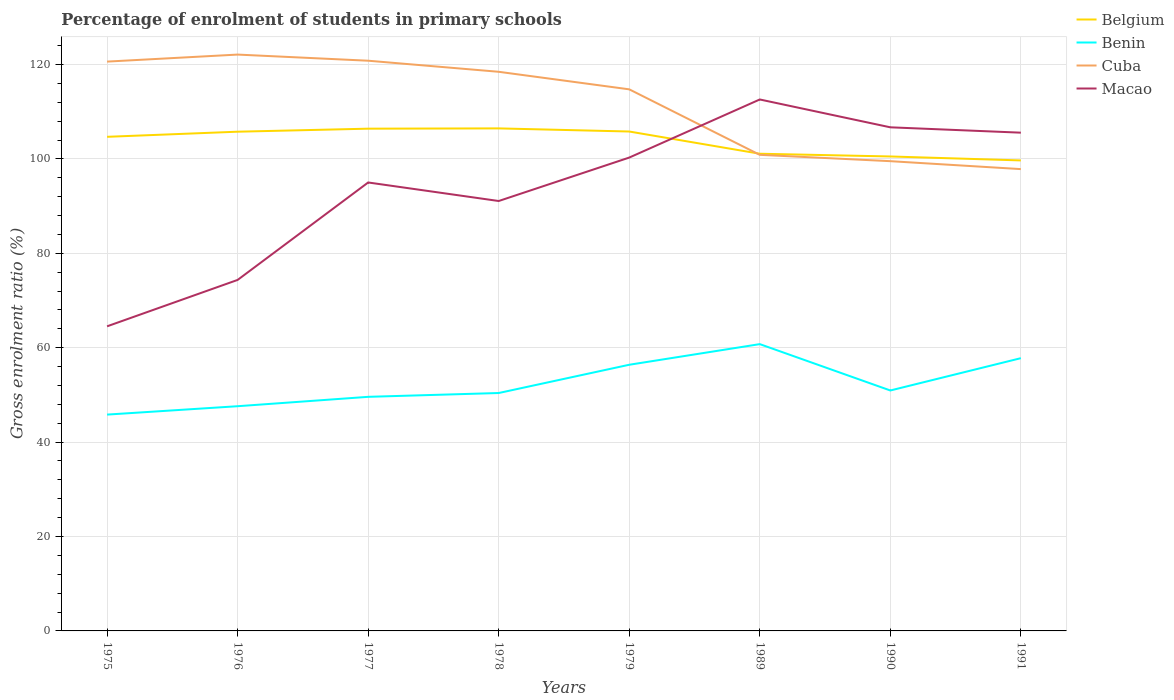How many different coloured lines are there?
Make the answer very short. 4. Does the line corresponding to Cuba intersect with the line corresponding to Macao?
Keep it short and to the point. Yes. Across all years, what is the maximum percentage of students enrolled in primary schools in Belgium?
Offer a terse response. 99.68. In which year was the percentage of students enrolled in primary schools in Belgium maximum?
Make the answer very short. 1991. What is the total percentage of students enrolled in primary schools in Cuba in the graph?
Keep it short and to the point. 3.03. What is the difference between the highest and the second highest percentage of students enrolled in primary schools in Benin?
Give a very brief answer. 14.93. What is the difference between the highest and the lowest percentage of students enrolled in primary schools in Cuba?
Offer a very short reply. 5. Are the values on the major ticks of Y-axis written in scientific E-notation?
Your answer should be compact. No. Where does the legend appear in the graph?
Keep it short and to the point. Top right. How many legend labels are there?
Offer a terse response. 4. How are the legend labels stacked?
Ensure brevity in your answer.  Vertical. What is the title of the graph?
Keep it short and to the point. Percentage of enrolment of students in primary schools. Does "Mauritania" appear as one of the legend labels in the graph?
Offer a very short reply. No. What is the label or title of the Y-axis?
Give a very brief answer. Gross enrolment ratio (%). What is the Gross enrolment ratio (%) in Belgium in 1975?
Give a very brief answer. 104.68. What is the Gross enrolment ratio (%) of Benin in 1975?
Your response must be concise. 45.83. What is the Gross enrolment ratio (%) in Cuba in 1975?
Your answer should be compact. 120.61. What is the Gross enrolment ratio (%) of Macao in 1975?
Your response must be concise. 64.53. What is the Gross enrolment ratio (%) of Belgium in 1976?
Ensure brevity in your answer.  105.76. What is the Gross enrolment ratio (%) of Benin in 1976?
Provide a succinct answer. 47.6. What is the Gross enrolment ratio (%) in Cuba in 1976?
Give a very brief answer. 122.1. What is the Gross enrolment ratio (%) in Macao in 1976?
Offer a very short reply. 74.36. What is the Gross enrolment ratio (%) of Belgium in 1977?
Give a very brief answer. 106.4. What is the Gross enrolment ratio (%) in Benin in 1977?
Your answer should be very brief. 49.59. What is the Gross enrolment ratio (%) of Cuba in 1977?
Ensure brevity in your answer.  120.8. What is the Gross enrolment ratio (%) of Macao in 1977?
Give a very brief answer. 95. What is the Gross enrolment ratio (%) of Belgium in 1978?
Provide a succinct answer. 106.46. What is the Gross enrolment ratio (%) of Benin in 1978?
Ensure brevity in your answer.  50.4. What is the Gross enrolment ratio (%) in Cuba in 1978?
Give a very brief answer. 118.45. What is the Gross enrolment ratio (%) in Macao in 1978?
Ensure brevity in your answer.  91.08. What is the Gross enrolment ratio (%) in Belgium in 1979?
Provide a succinct answer. 105.8. What is the Gross enrolment ratio (%) in Benin in 1979?
Keep it short and to the point. 56.39. What is the Gross enrolment ratio (%) of Cuba in 1979?
Your answer should be very brief. 114.73. What is the Gross enrolment ratio (%) in Macao in 1979?
Give a very brief answer. 100.28. What is the Gross enrolment ratio (%) in Belgium in 1989?
Offer a very short reply. 101.09. What is the Gross enrolment ratio (%) of Benin in 1989?
Keep it short and to the point. 60.76. What is the Gross enrolment ratio (%) of Cuba in 1989?
Your response must be concise. 100.86. What is the Gross enrolment ratio (%) of Macao in 1989?
Make the answer very short. 112.59. What is the Gross enrolment ratio (%) in Belgium in 1990?
Ensure brevity in your answer.  100.51. What is the Gross enrolment ratio (%) in Benin in 1990?
Offer a very short reply. 50.94. What is the Gross enrolment ratio (%) of Cuba in 1990?
Your answer should be very brief. 99.52. What is the Gross enrolment ratio (%) in Macao in 1990?
Keep it short and to the point. 106.69. What is the Gross enrolment ratio (%) in Belgium in 1991?
Give a very brief answer. 99.68. What is the Gross enrolment ratio (%) of Benin in 1991?
Your response must be concise. 57.78. What is the Gross enrolment ratio (%) of Cuba in 1991?
Make the answer very short. 97.83. What is the Gross enrolment ratio (%) in Macao in 1991?
Keep it short and to the point. 105.55. Across all years, what is the maximum Gross enrolment ratio (%) of Belgium?
Make the answer very short. 106.46. Across all years, what is the maximum Gross enrolment ratio (%) in Benin?
Give a very brief answer. 60.76. Across all years, what is the maximum Gross enrolment ratio (%) in Cuba?
Keep it short and to the point. 122.1. Across all years, what is the maximum Gross enrolment ratio (%) of Macao?
Your response must be concise. 112.59. Across all years, what is the minimum Gross enrolment ratio (%) of Belgium?
Your answer should be very brief. 99.68. Across all years, what is the minimum Gross enrolment ratio (%) in Benin?
Give a very brief answer. 45.83. Across all years, what is the minimum Gross enrolment ratio (%) of Cuba?
Offer a very short reply. 97.83. Across all years, what is the minimum Gross enrolment ratio (%) in Macao?
Provide a short and direct response. 64.53. What is the total Gross enrolment ratio (%) in Belgium in the graph?
Ensure brevity in your answer.  830.38. What is the total Gross enrolment ratio (%) in Benin in the graph?
Your answer should be very brief. 419.29. What is the total Gross enrolment ratio (%) in Cuba in the graph?
Keep it short and to the point. 894.9. What is the total Gross enrolment ratio (%) in Macao in the graph?
Offer a terse response. 750.08. What is the difference between the Gross enrolment ratio (%) in Belgium in 1975 and that in 1976?
Provide a succinct answer. -1.08. What is the difference between the Gross enrolment ratio (%) in Benin in 1975 and that in 1976?
Your answer should be compact. -1.78. What is the difference between the Gross enrolment ratio (%) in Cuba in 1975 and that in 1976?
Make the answer very short. -1.49. What is the difference between the Gross enrolment ratio (%) in Macao in 1975 and that in 1976?
Provide a succinct answer. -9.83. What is the difference between the Gross enrolment ratio (%) of Belgium in 1975 and that in 1977?
Provide a succinct answer. -1.72. What is the difference between the Gross enrolment ratio (%) in Benin in 1975 and that in 1977?
Keep it short and to the point. -3.76. What is the difference between the Gross enrolment ratio (%) of Cuba in 1975 and that in 1977?
Provide a succinct answer. -0.19. What is the difference between the Gross enrolment ratio (%) in Macao in 1975 and that in 1977?
Offer a terse response. -30.47. What is the difference between the Gross enrolment ratio (%) in Belgium in 1975 and that in 1978?
Offer a very short reply. -1.78. What is the difference between the Gross enrolment ratio (%) in Benin in 1975 and that in 1978?
Provide a succinct answer. -4.57. What is the difference between the Gross enrolment ratio (%) of Cuba in 1975 and that in 1978?
Provide a short and direct response. 2.16. What is the difference between the Gross enrolment ratio (%) in Macao in 1975 and that in 1978?
Offer a terse response. -26.55. What is the difference between the Gross enrolment ratio (%) of Belgium in 1975 and that in 1979?
Give a very brief answer. -1.12. What is the difference between the Gross enrolment ratio (%) in Benin in 1975 and that in 1979?
Your answer should be compact. -10.56. What is the difference between the Gross enrolment ratio (%) in Cuba in 1975 and that in 1979?
Your answer should be very brief. 5.88. What is the difference between the Gross enrolment ratio (%) of Macao in 1975 and that in 1979?
Ensure brevity in your answer.  -35.75. What is the difference between the Gross enrolment ratio (%) in Belgium in 1975 and that in 1989?
Make the answer very short. 3.58. What is the difference between the Gross enrolment ratio (%) in Benin in 1975 and that in 1989?
Your answer should be very brief. -14.93. What is the difference between the Gross enrolment ratio (%) in Cuba in 1975 and that in 1989?
Keep it short and to the point. 19.75. What is the difference between the Gross enrolment ratio (%) in Macao in 1975 and that in 1989?
Give a very brief answer. -48.06. What is the difference between the Gross enrolment ratio (%) of Belgium in 1975 and that in 1990?
Give a very brief answer. 4.16. What is the difference between the Gross enrolment ratio (%) in Benin in 1975 and that in 1990?
Offer a very short reply. -5.11. What is the difference between the Gross enrolment ratio (%) in Cuba in 1975 and that in 1990?
Your answer should be very brief. 21.09. What is the difference between the Gross enrolment ratio (%) in Macao in 1975 and that in 1990?
Provide a succinct answer. -42.16. What is the difference between the Gross enrolment ratio (%) of Belgium in 1975 and that in 1991?
Keep it short and to the point. 5. What is the difference between the Gross enrolment ratio (%) in Benin in 1975 and that in 1991?
Ensure brevity in your answer.  -11.95. What is the difference between the Gross enrolment ratio (%) in Cuba in 1975 and that in 1991?
Make the answer very short. 22.78. What is the difference between the Gross enrolment ratio (%) in Macao in 1975 and that in 1991?
Make the answer very short. -41.02. What is the difference between the Gross enrolment ratio (%) of Belgium in 1976 and that in 1977?
Make the answer very short. -0.64. What is the difference between the Gross enrolment ratio (%) in Benin in 1976 and that in 1977?
Ensure brevity in your answer.  -1.99. What is the difference between the Gross enrolment ratio (%) of Cuba in 1976 and that in 1977?
Offer a very short reply. 1.3. What is the difference between the Gross enrolment ratio (%) in Macao in 1976 and that in 1977?
Your answer should be compact. -20.64. What is the difference between the Gross enrolment ratio (%) in Belgium in 1976 and that in 1978?
Your answer should be very brief. -0.7. What is the difference between the Gross enrolment ratio (%) of Benin in 1976 and that in 1978?
Provide a succinct answer. -2.79. What is the difference between the Gross enrolment ratio (%) of Cuba in 1976 and that in 1978?
Your response must be concise. 3.65. What is the difference between the Gross enrolment ratio (%) of Macao in 1976 and that in 1978?
Provide a succinct answer. -16.72. What is the difference between the Gross enrolment ratio (%) in Belgium in 1976 and that in 1979?
Your response must be concise. -0.04. What is the difference between the Gross enrolment ratio (%) of Benin in 1976 and that in 1979?
Provide a short and direct response. -8.78. What is the difference between the Gross enrolment ratio (%) in Cuba in 1976 and that in 1979?
Give a very brief answer. 7.36. What is the difference between the Gross enrolment ratio (%) in Macao in 1976 and that in 1979?
Make the answer very short. -25.92. What is the difference between the Gross enrolment ratio (%) of Belgium in 1976 and that in 1989?
Offer a terse response. 4.67. What is the difference between the Gross enrolment ratio (%) in Benin in 1976 and that in 1989?
Keep it short and to the point. -13.15. What is the difference between the Gross enrolment ratio (%) of Cuba in 1976 and that in 1989?
Offer a terse response. 21.24. What is the difference between the Gross enrolment ratio (%) of Macao in 1976 and that in 1989?
Make the answer very short. -38.23. What is the difference between the Gross enrolment ratio (%) in Belgium in 1976 and that in 1990?
Your answer should be very brief. 5.25. What is the difference between the Gross enrolment ratio (%) of Benin in 1976 and that in 1990?
Provide a short and direct response. -3.33. What is the difference between the Gross enrolment ratio (%) of Cuba in 1976 and that in 1990?
Offer a terse response. 22.58. What is the difference between the Gross enrolment ratio (%) in Macao in 1976 and that in 1990?
Ensure brevity in your answer.  -32.33. What is the difference between the Gross enrolment ratio (%) in Belgium in 1976 and that in 1991?
Your answer should be very brief. 6.08. What is the difference between the Gross enrolment ratio (%) of Benin in 1976 and that in 1991?
Ensure brevity in your answer.  -10.18. What is the difference between the Gross enrolment ratio (%) in Cuba in 1976 and that in 1991?
Offer a very short reply. 24.27. What is the difference between the Gross enrolment ratio (%) of Macao in 1976 and that in 1991?
Your response must be concise. -31.19. What is the difference between the Gross enrolment ratio (%) in Belgium in 1977 and that in 1978?
Provide a short and direct response. -0.06. What is the difference between the Gross enrolment ratio (%) in Benin in 1977 and that in 1978?
Your answer should be compact. -0.81. What is the difference between the Gross enrolment ratio (%) in Cuba in 1977 and that in 1978?
Ensure brevity in your answer.  2.35. What is the difference between the Gross enrolment ratio (%) in Macao in 1977 and that in 1978?
Your answer should be very brief. 3.93. What is the difference between the Gross enrolment ratio (%) in Belgium in 1977 and that in 1979?
Make the answer very short. 0.6. What is the difference between the Gross enrolment ratio (%) in Benin in 1977 and that in 1979?
Give a very brief answer. -6.8. What is the difference between the Gross enrolment ratio (%) in Cuba in 1977 and that in 1979?
Keep it short and to the point. 6.06. What is the difference between the Gross enrolment ratio (%) of Macao in 1977 and that in 1979?
Keep it short and to the point. -5.27. What is the difference between the Gross enrolment ratio (%) in Belgium in 1977 and that in 1989?
Offer a very short reply. 5.31. What is the difference between the Gross enrolment ratio (%) in Benin in 1977 and that in 1989?
Keep it short and to the point. -11.17. What is the difference between the Gross enrolment ratio (%) of Cuba in 1977 and that in 1989?
Ensure brevity in your answer.  19.94. What is the difference between the Gross enrolment ratio (%) in Macao in 1977 and that in 1989?
Offer a very short reply. -17.58. What is the difference between the Gross enrolment ratio (%) of Belgium in 1977 and that in 1990?
Your answer should be compact. 5.89. What is the difference between the Gross enrolment ratio (%) of Benin in 1977 and that in 1990?
Your response must be concise. -1.35. What is the difference between the Gross enrolment ratio (%) in Cuba in 1977 and that in 1990?
Make the answer very short. 21.28. What is the difference between the Gross enrolment ratio (%) in Macao in 1977 and that in 1990?
Your response must be concise. -11.69. What is the difference between the Gross enrolment ratio (%) in Belgium in 1977 and that in 1991?
Make the answer very short. 6.72. What is the difference between the Gross enrolment ratio (%) in Benin in 1977 and that in 1991?
Your response must be concise. -8.19. What is the difference between the Gross enrolment ratio (%) in Cuba in 1977 and that in 1991?
Your answer should be very brief. 22.96. What is the difference between the Gross enrolment ratio (%) in Macao in 1977 and that in 1991?
Provide a succinct answer. -10.55. What is the difference between the Gross enrolment ratio (%) of Belgium in 1978 and that in 1979?
Provide a succinct answer. 0.66. What is the difference between the Gross enrolment ratio (%) in Benin in 1978 and that in 1979?
Provide a succinct answer. -5.99. What is the difference between the Gross enrolment ratio (%) of Cuba in 1978 and that in 1979?
Your response must be concise. 3.72. What is the difference between the Gross enrolment ratio (%) of Macao in 1978 and that in 1979?
Ensure brevity in your answer.  -9.2. What is the difference between the Gross enrolment ratio (%) of Belgium in 1978 and that in 1989?
Offer a terse response. 5.37. What is the difference between the Gross enrolment ratio (%) in Benin in 1978 and that in 1989?
Your response must be concise. -10.36. What is the difference between the Gross enrolment ratio (%) in Cuba in 1978 and that in 1989?
Offer a terse response. 17.59. What is the difference between the Gross enrolment ratio (%) in Macao in 1978 and that in 1989?
Offer a terse response. -21.51. What is the difference between the Gross enrolment ratio (%) in Belgium in 1978 and that in 1990?
Offer a terse response. 5.95. What is the difference between the Gross enrolment ratio (%) of Benin in 1978 and that in 1990?
Provide a succinct answer. -0.54. What is the difference between the Gross enrolment ratio (%) in Cuba in 1978 and that in 1990?
Make the answer very short. 18.94. What is the difference between the Gross enrolment ratio (%) in Macao in 1978 and that in 1990?
Your answer should be compact. -15.61. What is the difference between the Gross enrolment ratio (%) in Belgium in 1978 and that in 1991?
Provide a short and direct response. 6.78. What is the difference between the Gross enrolment ratio (%) of Benin in 1978 and that in 1991?
Ensure brevity in your answer.  -7.38. What is the difference between the Gross enrolment ratio (%) of Cuba in 1978 and that in 1991?
Your answer should be very brief. 20.62. What is the difference between the Gross enrolment ratio (%) of Macao in 1978 and that in 1991?
Provide a short and direct response. -14.48. What is the difference between the Gross enrolment ratio (%) of Belgium in 1979 and that in 1989?
Give a very brief answer. 4.7. What is the difference between the Gross enrolment ratio (%) of Benin in 1979 and that in 1989?
Your answer should be very brief. -4.37. What is the difference between the Gross enrolment ratio (%) of Cuba in 1979 and that in 1989?
Provide a short and direct response. 13.88. What is the difference between the Gross enrolment ratio (%) of Macao in 1979 and that in 1989?
Offer a very short reply. -12.31. What is the difference between the Gross enrolment ratio (%) in Belgium in 1979 and that in 1990?
Give a very brief answer. 5.28. What is the difference between the Gross enrolment ratio (%) in Benin in 1979 and that in 1990?
Provide a short and direct response. 5.45. What is the difference between the Gross enrolment ratio (%) of Cuba in 1979 and that in 1990?
Provide a succinct answer. 15.22. What is the difference between the Gross enrolment ratio (%) in Macao in 1979 and that in 1990?
Offer a very short reply. -6.41. What is the difference between the Gross enrolment ratio (%) in Belgium in 1979 and that in 1991?
Your answer should be very brief. 6.12. What is the difference between the Gross enrolment ratio (%) in Benin in 1979 and that in 1991?
Give a very brief answer. -1.39. What is the difference between the Gross enrolment ratio (%) in Cuba in 1979 and that in 1991?
Your answer should be compact. 16.9. What is the difference between the Gross enrolment ratio (%) in Macao in 1979 and that in 1991?
Keep it short and to the point. -5.28. What is the difference between the Gross enrolment ratio (%) in Belgium in 1989 and that in 1990?
Give a very brief answer. 0.58. What is the difference between the Gross enrolment ratio (%) in Benin in 1989 and that in 1990?
Offer a very short reply. 9.82. What is the difference between the Gross enrolment ratio (%) in Cuba in 1989 and that in 1990?
Ensure brevity in your answer.  1.34. What is the difference between the Gross enrolment ratio (%) in Macao in 1989 and that in 1990?
Make the answer very short. 5.9. What is the difference between the Gross enrolment ratio (%) of Belgium in 1989 and that in 1991?
Keep it short and to the point. 1.42. What is the difference between the Gross enrolment ratio (%) in Benin in 1989 and that in 1991?
Give a very brief answer. 2.98. What is the difference between the Gross enrolment ratio (%) of Cuba in 1989 and that in 1991?
Your answer should be compact. 3.03. What is the difference between the Gross enrolment ratio (%) in Macao in 1989 and that in 1991?
Give a very brief answer. 7.03. What is the difference between the Gross enrolment ratio (%) of Belgium in 1990 and that in 1991?
Offer a terse response. 0.84. What is the difference between the Gross enrolment ratio (%) in Benin in 1990 and that in 1991?
Offer a very short reply. -6.84. What is the difference between the Gross enrolment ratio (%) of Cuba in 1990 and that in 1991?
Your answer should be very brief. 1.68. What is the difference between the Gross enrolment ratio (%) of Macao in 1990 and that in 1991?
Offer a very short reply. 1.14. What is the difference between the Gross enrolment ratio (%) of Belgium in 1975 and the Gross enrolment ratio (%) of Benin in 1976?
Provide a succinct answer. 57.07. What is the difference between the Gross enrolment ratio (%) of Belgium in 1975 and the Gross enrolment ratio (%) of Cuba in 1976?
Your answer should be compact. -17.42. What is the difference between the Gross enrolment ratio (%) in Belgium in 1975 and the Gross enrolment ratio (%) in Macao in 1976?
Your response must be concise. 30.32. What is the difference between the Gross enrolment ratio (%) in Benin in 1975 and the Gross enrolment ratio (%) in Cuba in 1976?
Your answer should be very brief. -76.27. What is the difference between the Gross enrolment ratio (%) in Benin in 1975 and the Gross enrolment ratio (%) in Macao in 1976?
Your response must be concise. -28.53. What is the difference between the Gross enrolment ratio (%) in Cuba in 1975 and the Gross enrolment ratio (%) in Macao in 1976?
Your answer should be very brief. 46.25. What is the difference between the Gross enrolment ratio (%) of Belgium in 1975 and the Gross enrolment ratio (%) of Benin in 1977?
Provide a short and direct response. 55.08. What is the difference between the Gross enrolment ratio (%) in Belgium in 1975 and the Gross enrolment ratio (%) in Cuba in 1977?
Ensure brevity in your answer.  -16.12. What is the difference between the Gross enrolment ratio (%) of Belgium in 1975 and the Gross enrolment ratio (%) of Macao in 1977?
Keep it short and to the point. 9.67. What is the difference between the Gross enrolment ratio (%) of Benin in 1975 and the Gross enrolment ratio (%) of Cuba in 1977?
Your response must be concise. -74.97. What is the difference between the Gross enrolment ratio (%) in Benin in 1975 and the Gross enrolment ratio (%) in Macao in 1977?
Your answer should be very brief. -49.17. What is the difference between the Gross enrolment ratio (%) of Cuba in 1975 and the Gross enrolment ratio (%) of Macao in 1977?
Offer a terse response. 25.61. What is the difference between the Gross enrolment ratio (%) in Belgium in 1975 and the Gross enrolment ratio (%) in Benin in 1978?
Make the answer very short. 54.28. What is the difference between the Gross enrolment ratio (%) in Belgium in 1975 and the Gross enrolment ratio (%) in Cuba in 1978?
Offer a terse response. -13.78. What is the difference between the Gross enrolment ratio (%) of Belgium in 1975 and the Gross enrolment ratio (%) of Macao in 1978?
Provide a succinct answer. 13.6. What is the difference between the Gross enrolment ratio (%) of Benin in 1975 and the Gross enrolment ratio (%) of Cuba in 1978?
Provide a succinct answer. -72.62. What is the difference between the Gross enrolment ratio (%) of Benin in 1975 and the Gross enrolment ratio (%) of Macao in 1978?
Your response must be concise. -45.25. What is the difference between the Gross enrolment ratio (%) of Cuba in 1975 and the Gross enrolment ratio (%) of Macao in 1978?
Provide a short and direct response. 29.53. What is the difference between the Gross enrolment ratio (%) of Belgium in 1975 and the Gross enrolment ratio (%) of Benin in 1979?
Ensure brevity in your answer.  48.29. What is the difference between the Gross enrolment ratio (%) of Belgium in 1975 and the Gross enrolment ratio (%) of Cuba in 1979?
Offer a terse response. -10.06. What is the difference between the Gross enrolment ratio (%) of Belgium in 1975 and the Gross enrolment ratio (%) of Macao in 1979?
Your answer should be compact. 4.4. What is the difference between the Gross enrolment ratio (%) in Benin in 1975 and the Gross enrolment ratio (%) in Cuba in 1979?
Provide a succinct answer. -68.91. What is the difference between the Gross enrolment ratio (%) in Benin in 1975 and the Gross enrolment ratio (%) in Macao in 1979?
Give a very brief answer. -54.45. What is the difference between the Gross enrolment ratio (%) of Cuba in 1975 and the Gross enrolment ratio (%) of Macao in 1979?
Make the answer very short. 20.33. What is the difference between the Gross enrolment ratio (%) of Belgium in 1975 and the Gross enrolment ratio (%) of Benin in 1989?
Give a very brief answer. 43.92. What is the difference between the Gross enrolment ratio (%) of Belgium in 1975 and the Gross enrolment ratio (%) of Cuba in 1989?
Provide a short and direct response. 3.82. What is the difference between the Gross enrolment ratio (%) of Belgium in 1975 and the Gross enrolment ratio (%) of Macao in 1989?
Your answer should be compact. -7.91. What is the difference between the Gross enrolment ratio (%) of Benin in 1975 and the Gross enrolment ratio (%) of Cuba in 1989?
Offer a very short reply. -55.03. What is the difference between the Gross enrolment ratio (%) of Benin in 1975 and the Gross enrolment ratio (%) of Macao in 1989?
Make the answer very short. -66.76. What is the difference between the Gross enrolment ratio (%) in Cuba in 1975 and the Gross enrolment ratio (%) in Macao in 1989?
Ensure brevity in your answer.  8.02. What is the difference between the Gross enrolment ratio (%) of Belgium in 1975 and the Gross enrolment ratio (%) of Benin in 1990?
Keep it short and to the point. 53.74. What is the difference between the Gross enrolment ratio (%) in Belgium in 1975 and the Gross enrolment ratio (%) in Cuba in 1990?
Give a very brief answer. 5.16. What is the difference between the Gross enrolment ratio (%) in Belgium in 1975 and the Gross enrolment ratio (%) in Macao in 1990?
Your answer should be very brief. -2.01. What is the difference between the Gross enrolment ratio (%) of Benin in 1975 and the Gross enrolment ratio (%) of Cuba in 1990?
Give a very brief answer. -53.69. What is the difference between the Gross enrolment ratio (%) in Benin in 1975 and the Gross enrolment ratio (%) in Macao in 1990?
Your answer should be very brief. -60.86. What is the difference between the Gross enrolment ratio (%) in Cuba in 1975 and the Gross enrolment ratio (%) in Macao in 1990?
Offer a terse response. 13.92. What is the difference between the Gross enrolment ratio (%) of Belgium in 1975 and the Gross enrolment ratio (%) of Benin in 1991?
Make the answer very short. 46.89. What is the difference between the Gross enrolment ratio (%) in Belgium in 1975 and the Gross enrolment ratio (%) in Cuba in 1991?
Offer a terse response. 6.84. What is the difference between the Gross enrolment ratio (%) of Belgium in 1975 and the Gross enrolment ratio (%) of Macao in 1991?
Provide a short and direct response. -0.88. What is the difference between the Gross enrolment ratio (%) in Benin in 1975 and the Gross enrolment ratio (%) in Cuba in 1991?
Offer a very short reply. -52.01. What is the difference between the Gross enrolment ratio (%) of Benin in 1975 and the Gross enrolment ratio (%) of Macao in 1991?
Ensure brevity in your answer.  -59.72. What is the difference between the Gross enrolment ratio (%) of Cuba in 1975 and the Gross enrolment ratio (%) of Macao in 1991?
Give a very brief answer. 15.06. What is the difference between the Gross enrolment ratio (%) of Belgium in 1976 and the Gross enrolment ratio (%) of Benin in 1977?
Provide a succinct answer. 56.17. What is the difference between the Gross enrolment ratio (%) of Belgium in 1976 and the Gross enrolment ratio (%) of Cuba in 1977?
Provide a succinct answer. -15.04. What is the difference between the Gross enrolment ratio (%) of Belgium in 1976 and the Gross enrolment ratio (%) of Macao in 1977?
Your answer should be compact. 10.76. What is the difference between the Gross enrolment ratio (%) in Benin in 1976 and the Gross enrolment ratio (%) in Cuba in 1977?
Keep it short and to the point. -73.19. What is the difference between the Gross enrolment ratio (%) in Benin in 1976 and the Gross enrolment ratio (%) in Macao in 1977?
Your answer should be very brief. -47.4. What is the difference between the Gross enrolment ratio (%) of Cuba in 1976 and the Gross enrolment ratio (%) of Macao in 1977?
Make the answer very short. 27.1. What is the difference between the Gross enrolment ratio (%) in Belgium in 1976 and the Gross enrolment ratio (%) in Benin in 1978?
Make the answer very short. 55.36. What is the difference between the Gross enrolment ratio (%) of Belgium in 1976 and the Gross enrolment ratio (%) of Cuba in 1978?
Give a very brief answer. -12.69. What is the difference between the Gross enrolment ratio (%) in Belgium in 1976 and the Gross enrolment ratio (%) in Macao in 1978?
Your answer should be compact. 14.68. What is the difference between the Gross enrolment ratio (%) of Benin in 1976 and the Gross enrolment ratio (%) of Cuba in 1978?
Make the answer very short. -70.85. What is the difference between the Gross enrolment ratio (%) in Benin in 1976 and the Gross enrolment ratio (%) in Macao in 1978?
Your response must be concise. -43.47. What is the difference between the Gross enrolment ratio (%) in Cuba in 1976 and the Gross enrolment ratio (%) in Macao in 1978?
Offer a very short reply. 31.02. What is the difference between the Gross enrolment ratio (%) of Belgium in 1976 and the Gross enrolment ratio (%) of Benin in 1979?
Provide a short and direct response. 49.37. What is the difference between the Gross enrolment ratio (%) of Belgium in 1976 and the Gross enrolment ratio (%) of Cuba in 1979?
Your answer should be very brief. -8.97. What is the difference between the Gross enrolment ratio (%) in Belgium in 1976 and the Gross enrolment ratio (%) in Macao in 1979?
Provide a short and direct response. 5.48. What is the difference between the Gross enrolment ratio (%) of Benin in 1976 and the Gross enrolment ratio (%) of Cuba in 1979?
Keep it short and to the point. -67.13. What is the difference between the Gross enrolment ratio (%) in Benin in 1976 and the Gross enrolment ratio (%) in Macao in 1979?
Your answer should be very brief. -52.67. What is the difference between the Gross enrolment ratio (%) of Cuba in 1976 and the Gross enrolment ratio (%) of Macao in 1979?
Give a very brief answer. 21.82. What is the difference between the Gross enrolment ratio (%) of Belgium in 1976 and the Gross enrolment ratio (%) of Benin in 1989?
Offer a very short reply. 45. What is the difference between the Gross enrolment ratio (%) in Belgium in 1976 and the Gross enrolment ratio (%) in Cuba in 1989?
Provide a short and direct response. 4.9. What is the difference between the Gross enrolment ratio (%) of Belgium in 1976 and the Gross enrolment ratio (%) of Macao in 1989?
Your answer should be compact. -6.83. What is the difference between the Gross enrolment ratio (%) in Benin in 1976 and the Gross enrolment ratio (%) in Cuba in 1989?
Your answer should be very brief. -53.25. What is the difference between the Gross enrolment ratio (%) in Benin in 1976 and the Gross enrolment ratio (%) in Macao in 1989?
Offer a very short reply. -64.98. What is the difference between the Gross enrolment ratio (%) in Cuba in 1976 and the Gross enrolment ratio (%) in Macao in 1989?
Keep it short and to the point. 9.51. What is the difference between the Gross enrolment ratio (%) of Belgium in 1976 and the Gross enrolment ratio (%) of Benin in 1990?
Offer a very short reply. 54.82. What is the difference between the Gross enrolment ratio (%) of Belgium in 1976 and the Gross enrolment ratio (%) of Cuba in 1990?
Your answer should be compact. 6.24. What is the difference between the Gross enrolment ratio (%) in Belgium in 1976 and the Gross enrolment ratio (%) in Macao in 1990?
Keep it short and to the point. -0.93. What is the difference between the Gross enrolment ratio (%) in Benin in 1976 and the Gross enrolment ratio (%) in Cuba in 1990?
Make the answer very short. -51.91. What is the difference between the Gross enrolment ratio (%) in Benin in 1976 and the Gross enrolment ratio (%) in Macao in 1990?
Ensure brevity in your answer.  -59.08. What is the difference between the Gross enrolment ratio (%) of Cuba in 1976 and the Gross enrolment ratio (%) of Macao in 1990?
Your answer should be very brief. 15.41. What is the difference between the Gross enrolment ratio (%) in Belgium in 1976 and the Gross enrolment ratio (%) in Benin in 1991?
Offer a terse response. 47.98. What is the difference between the Gross enrolment ratio (%) in Belgium in 1976 and the Gross enrolment ratio (%) in Cuba in 1991?
Your answer should be very brief. 7.93. What is the difference between the Gross enrolment ratio (%) of Belgium in 1976 and the Gross enrolment ratio (%) of Macao in 1991?
Your answer should be compact. 0.21. What is the difference between the Gross enrolment ratio (%) in Benin in 1976 and the Gross enrolment ratio (%) in Cuba in 1991?
Provide a succinct answer. -50.23. What is the difference between the Gross enrolment ratio (%) in Benin in 1976 and the Gross enrolment ratio (%) in Macao in 1991?
Offer a very short reply. -57.95. What is the difference between the Gross enrolment ratio (%) in Cuba in 1976 and the Gross enrolment ratio (%) in Macao in 1991?
Your answer should be compact. 16.55. What is the difference between the Gross enrolment ratio (%) of Belgium in 1977 and the Gross enrolment ratio (%) of Benin in 1978?
Your answer should be compact. 56. What is the difference between the Gross enrolment ratio (%) in Belgium in 1977 and the Gross enrolment ratio (%) in Cuba in 1978?
Provide a short and direct response. -12.05. What is the difference between the Gross enrolment ratio (%) in Belgium in 1977 and the Gross enrolment ratio (%) in Macao in 1978?
Keep it short and to the point. 15.32. What is the difference between the Gross enrolment ratio (%) of Benin in 1977 and the Gross enrolment ratio (%) of Cuba in 1978?
Your response must be concise. -68.86. What is the difference between the Gross enrolment ratio (%) of Benin in 1977 and the Gross enrolment ratio (%) of Macao in 1978?
Give a very brief answer. -41.49. What is the difference between the Gross enrolment ratio (%) of Cuba in 1977 and the Gross enrolment ratio (%) of Macao in 1978?
Provide a succinct answer. 29.72. What is the difference between the Gross enrolment ratio (%) in Belgium in 1977 and the Gross enrolment ratio (%) in Benin in 1979?
Offer a terse response. 50.01. What is the difference between the Gross enrolment ratio (%) of Belgium in 1977 and the Gross enrolment ratio (%) of Cuba in 1979?
Give a very brief answer. -8.33. What is the difference between the Gross enrolment ratio (%) of Belgium in 1977 and the Gross enrolment ratio (%) of Macao in 1979?
Make the answer very short. 6.12. What is the difference between the Gross enrolment ratio (%) in Benin in 1977 and the Gross enrolment ratio (%) in Cuba in 1979?
Provide a short and direct response. -65.14. What is the difference between the Gross enrolment ratio (%) of Benin in 1977 and the Gross enrolment ratio (%) of Macao in 1979?
Make the answer very short. -50.69. What is the difference between the Gross enrolment ratio (%) of Cuba in 1977 and the Gross enrolment ratio (%) of Macao in 1979?
Your answer should be very brief. 20.52. What is the difference between the Gross enrolment ratio (%) of Belgium in 1977 and the Gross enrolment ratio (%) of Benin in 1989?
Offer a terse response. 45.64. What is the difference between the Gross enrolment ratio (%) of Belgium in 1977 and the Gross enrolment ratio (%) of Cuba in 1989?
Offer a very short reply. 5.54. What is the difference between the Gross enrolment ratio (%) in Belgium in 1977 and the Gross enrolment ratio (%) in Macao in 1989?
Your response must be concise. -6.18. What is the difference between the Gross enrolment ratio (%) in Benin in 1977 and the Gross enrolment ratio (%) in Cuba in 1989?
Keep it short and to the point. -51.27. What is the difference between the Gross enrolment ratio (%) in Benin in 1977 and the Gross enrolment ratio (%) in Macao in 1989?
Your answer should be very brief. -62.99. What is the difference between the Gross enrolment ratio (%) in Cuba in 1977 and the Gross enrolment ratio (%) in Macao in 1989?
Keep it short and to the point. 8.21. What is the difference between the Gross enrolment ratio (%) of Belgium in 1977 and the Gross enrolment ratio (%) of Benin in 1990?
Provide a short and direct response. 55.46. What is the difference between the Gross enrolment ratio (%) of Belgium in 1977 and the Gross enrolment ratio (%) of Cuba in 1990?
Ensure brevity in your answer.  6.88. What is the difference between the Gross enrolment ratio (%) in Belgium in 1977 and the Gross enrolment ratio (%) in Macao in 1990?
Ensure brevity in your answer.  -0.29. What is the difference between the Gross enrolment ratio (%) of Benin in 1977 and the Gross enrolment ratio (%) of Cuba in 1990?
Ensure brevity in your answer.  -49.93. What is the difference between the Gross enrolment ratio (%) of Benin in 1977 and the Gross enrolment ratio (%) of Macao in 1990?
Provide a succinct answer. -57.1. What is the difference between the Gross enrolment ratio (%) of Cuba in 1977 and the Gross enrolment ratio (%) of Macao in 1990?
Offer a very short reply. 14.11. What is the difference between the Gross enrolment ratio (%) of Belgium in 1977 and the Gross enrolment ratio (%) of Benin in 1991?
Make the answer very short. 48.62. What is the difference between the Gross enrolment ratio (%) of Belgium in 1977 and the Gross enrolment ratio (%) of Cuba in 1991?
Your answer should be compact. 8.57. What is the difference between the Gross enrolment ratio (%) of Belgium in 1977 and the Gross enrolment ratio (%) of Macao in 1991?
Keep it short and to the point. 0.85. What is the difference between the Gross enrolment ratio (%) in Benin in 1977 and the Gross enrolment ratio (%) in Cuba in 1991?
Make the answer very short. -48.24. What is the difference between the Gross enrolment ratio (%) in Benin in 1977 and the Gross enrolment ratio (%) in Macao in 1991?
Provide a succinct answer. -55.96. What is the difference between the Gross enrolment ratio (%) in Cuba in 1977 and the Gross enrolment ratio (%) in Macao in 1991?
Your answer should be very brief. 15.24. What is the difference between the Gross enrolment ratio (%) in Belgium in 1978 and the Gross enrolment ratio (%) in Benin in 1979?
Your answer should be very brief. 50.07. What is the difference between the Gross enrolment ratio (%) in Belgium in 1978 and the Gross enrolment ratio (%) in Cuba in 1979?
Provide a short and direct response. -8.27. What is the difference between the Gross enrolment ratio (%) in Belgium in 1978 and the Gross enrolment ratio (%) in Macao in 1979?
Your answer should be compact. 6.18. What is the difference between the Gross enrolment ratio (%) of Benin in 1978 and the Gross enrolment ratio (%) of Cuba in 1979?
Ensure brevity in your answer.  -64.34. What is the difference between the Gross enrolment ratio (%) of Benin in 1978 and the Gross enrolment ratio (%) of Macao in 1979?
Keep it short and to the point. -49.88. What is the difference between the Gross enrolment ratio (%) in Cuba in 1978 and the Gross enrolment ratio (%) in Macao in 1979?
Provide a short and direct response. 18.17. What is the difference between the Gross enrolment ratio (%) of Belgium in 1978 and the Gross enrolment ratio (%) of Benin in 1989?
Your response must be concise. 45.7. What is the difference between the Gross enrolment ratio (%) in Belgium in 1978 and the Gross enrolment ratio (%) in Cuba in 1989?
Provide a short and direct response. 5.6. What is the difference between the Gross enrolment ratio (%) of Belgium in 1978 and the Gross enrolment ratio (%) of Macao in 1989?
Give a very brief answer. -6.13. What is the difference between the Gross enrolment ratio (%) in Benin in 1978 and the Gross enrolment ratio (%) in Cuba in 1989?
Give a very brief answer. -50.46. What is the difference between the Gross enrolment ratio (%) of Benin in 1978 and the Gross enrolment ratio (%) of Macao in 1989?
Give a very brief answer. -62.19. What is the difference between the Gross enrolment ratio (%) in Cuba in 1978 and the Gross enrolment ratio (%) in Macao in 1989?
Provide a short and direct response. 5.87. What is the difference between the Gross enrolment ratio (%) in Belgium in 1978 and the Gross enrolment ratio (%) in Benin in 1990?
Keep it short and to the point. 55.52. What is the difference between the Gross enrolment ratio (%) of Belgium in 1978 and the Gross enrolment ratio (%) of Cuba in 1990?
Your answer should be compact. 6.94. What is the difference between the Gross enrolment ratio (%) of Belgium in 1978 and the Gross enrolment ratio (%) of Macao in 1990?
Give a very brief answer. -0.23. What is the difference between the Gross enrolment ratio (%) of Benin in 1978 and the Gross enrolment ratio (%) of Cuba in 1990?
Provide a succinct answer. -49.12. What is the difference between the Gross enrolment ratio (%) of Benin in 1978 and the Gross enrolment ratio (%) of Macao in 1990?
Your response must be concise. -56.29. What is the difference between the Gross enrolment ratio (%) of Cuba in 1978 and the Gross enrolment ratio (%) of Macao in 1990?
Offer a very short reply. 11.76. What is the difference between the Gross enrolment ratio (%) in Belgium in 1978 and the Gross enrolment ratio (%) in Benin in 1991?
Your answer should be compact. 48.68. What is the difference between the Gross enrolment ratio (%) in Belgium in 1978 and the Gross enrolment ratio (%) in Cuba in 1991?
Offer a very short reply. 8.63. What is the difference between the Gross enrolment ratio (%) of Belgium in 1978 and the Gross enrolment ratio (%) of Macao in 1991?
Make the answer very short. 0.91. What is the difference between the Gross enrolment ratio (%) of Benin in 1978 and the Gross enrolment ratio (%) of Cuba in 1991?
Keep it short and to the point. -47.43. What is the difference between the Gross enrolment ratio (%) in Benin in 1978 and the Gross enrolment ratio (%) in Macao in 1991?
Make the answer very short. -55.15. What is the difference between the Gross enrolment ratio (%) of Cuba in 1978 and the Gross enrolment ratio (%) of Macao in 1991?
Your response must be concise. 12.9. What is the difference between the Gross enrolment ratio (%) of Belgium in 1979 and the Gross enrolment ratio (%) of Benin in 1989?
Your answer should be compact. 45.04. What is the difference between the Gross enrolment ratio (%) in Belgium in 1979 and the Gross enrolment ratio (%) in Cuba in 1989?
Your answer should be very brief. 4.94. What is the difference between the Gross enrolment ratio (%) in Belgium in 1979 and the Gross enrolment ratio (%) in Macao in 1989?
Make the answer very short. -6.79. What is the difference between the Gross enrolment ratio (%) in Benin in 1979 and the Gross enrolment ratio (%) in Cuba in 1989?
Ensure brevity in your answer.  -44.47. What is the difference between the Gross enrolment ratio (%) in Benin in 1979 and the Gross enrolment ratio (%) in Macao in 1989?
Offer a terse response. -56.2. What is the difference between the Gross enrolment ratio (%) in Cuba in 1979 and the Gross enrolment ratio (%) in Macao in 1989?
Offer a terse response. 2.15. What is the difference between the Gross enrolment ratio (%) of Belgium in 1979 and the Gross enrolment ratio (%) of Benin in 1990?
Make the answer very short. 54.86. What is the difference between the Gross enrolment ratio (%) in Belgium in 1979 and the Gross enrolment ratio (%) in Cuba in 1990?
Provide a succinct answer. 6.28. What is the difference between the Gross enrolment ratio (%) in Belgium in 1979 and the Gross enrolment ratio (%) in Macao in 1990?
Your answer should be very brief. -0.89. What is the difference between the Gross enrolment ratio (%) in Benin in 1979 and the Gross enrolment ratio (%) in Cuba in 1990?
Your answer should be very brief. -43.13. What is the difference between the Gross enrolment ratio (%) in Benin in 1979 and the Gross enrolment ratio (%) in Macao in 1990?
Your response must be concise. -50.3. What is the difference between the Gross enrolment ratio (%) in Cuba in 1979 and the Gross enrolment ratio (%) in Macao in 1990?
Keep it short and to the point. 8.04. What is the difference between the Gross enrolment ratio (%) in Belgium in 1979 and the Gross enrolment ratio (%) in Benin in 1991?
Offer a very short reply. 48.02. What is the difference between the Gross enrolment ratio (%) in Belgium in 1979 and the Gross enrolment ratio (%) in Cuba in 1991?
Your response must be concise. 7.96. What is the difference between the Gross enrolment ratio (%) of Belgium in 1979 and the Gross enrolment ratio (%) of Macao in 1991?
Make the answer very short. 0.24. What is the difference between the Gross enrolment ratio (%) in Benin in 1979 and the Gross enrolment ratio (%) in Cuba in 1991?
Make the answer very short. -41.45. What is the difference between the Gross enrolment ratio (%) in Benin in 1979 and the Gross enrolment ratio (%) in Macao in 1991?
Give a very brief answer. -49.17. What is the difference between the Gross enrolment ratio (%) of Cuba in 1979 and the Gross enrolment ratio (%) of Macao in 1991?
Make the answer very short. 9.18. What is the difference between the Gross enrolment ratio (%) in Belgium in 1989 and the Gross enrolment ratio (%) in Benin in 1990?
Make the answer very short. 50.16. What is the difference between the Gross enrolment ratio (%) in Belgium in 1989 and the Gross enrolment ratio (%) in Cuba in 1990?
Provide a succinct answer. 1.58. What is the difference between the Gross enrolment ratio (%) of Belgium in 1989 and the Gross enrolment ratio (%) of Macao in 1990?
Offer a terse response. -5.6. What is the difference between the Gross enrolment ratio (%) of Benin in 1989 and the Gross enrolment ratio (%) of Cuba in 1990?
Your answer should be very brief. -38.76. What is the difference between the Gross enrolment ratio (%) in Benin in 1989 and the Gross enrolment ratio (%) in Macao in 1990?
Offer a very short reply. -45.93. What is the difference between the Gross enrolment ratio (%) of Cuba in 1989 and the Gross enrolment ratio (%) of Macao in 1990?
Offer a terse response. -5.83. What is the difference between the Gross enrolment ratio (%) of Belgium in 1989 and the Gross enrolment ratio (%) of Benin in 1991?
Offer a very short reply. 43.31. What is the difference between the Gross enrolment ratio (%) of Belgium in 1989 and the Gross enrolment ratio (%) of Cuba in 1991?
Keep it short and to the point. 3.26. What is the difference between the Gross enrolment ratio (%) in Belgium in 1989 and the Gross enrolment ratio (%) in Macao in 1991?
Provide a short and direct response. -4.46. What is the difference between the Gross enrolment ratio (%) in Benin in 1989 and the Gross enrolment ratio (%) in Cuba in 1991?
Offer a terse response. -37.08. What is the difference between the Gross enrolment ratio (%) of Benin in 1989 and the Gross enrolment ratio (%) of Macao in 1991?
Provide a succinct answer. -44.8. What is the difference between the Gross enrolment ratio (%) in Cuba in 1989 and the Gross enrolment ratio (%) in Macao in 1991?
Provide a succinct answer. -4.69. What is the difference between the Gross enrolment ratio (%) of Belgium in 1990 and the Gross enrolment ratio (%) of Benin in 1991?
Offer a terse response. 42.73. What is the difference between the Gross enrolment ratio (%) in Belgium in 1990 and the Gross enrolment ratio (%) in Cuba in 1991?
Your answer should be very brief. 2.68. What is the difference between the Gross enrolment ratio (%) of Belgium in 1990 and the Gross enrolment ratio (%) of Macao in 1991?
Ensure brevity in your answer.  -5.04. What is the difference between the Gross enrolment ratio (%) in Benin in 1990 and the Gross enrolment ratio (%) in Cuba in 1991?
Ensure brevity in your answer.  -46.9. What is the difference between the Gross enrolment ratio (%) in Benin in 1990 and the Gross enrolment ratio (%) in Macao in 1991?
Give a very brief answer. -54.62. What is the difference between the Gross enrolment ratio (%) in Cuba in 1990 and the Gross enrolment ratio (%) in Macao in 1991?
Provide a short and direct response. -6.04. What is the average Gross enrolment ratio (%) in Belgium per year?
Ensure brevity in your answer.  103.8. What is the average Gross enrolment ratio (%) in Benin per year?
Provide a short and direct response. 52.41. What is the average Gross enrolment ratio (%) of Cuba per year?
Your answer should be very brief. 111.86. What is the average Gross enrolment ratio (%) of Macao per year?
Your answer should be very brief. 93.76. In the year 1975, what is the difference between the Gross enrolment ratio (%) in Belgium and Gross enrolment ratio (%) in Benin?
Offer a very short reply. 58.85. In the year 1975, what is the difference between the Gross enrolment ratio (%) of Belgium and Gross enrolment ratio (%) of Cuba?
Your response must be concise. -15.93. In the year 1975, what is the difference between the Gross enrolment ratio (%) of Belgium and Gross enrolment ratio (%) of Macao?
Your answer should be very brief. 40.15. In the year 1975, what is the difference between the Gross enrolment ratio (%) in Benin and Gross enrolment ratio (%) in Cuba?
Provide a short and direct response. -74.78. In the year 1975, what is the difference between the Gross enrolment ratio (%) in Benin and Gross enrolment ratio (%) in Macao?
Provide a short and direct response. -18.7. In the year 1975, what is the difference between the Gross enrolment ratio (%) in Cuba and Gross enrolment ratio (%) in Macao?
Your answer should be compact. 56.08. In the year 1976, what is the difference between the Gross enrolment ratio (%) in Belgium and Gross enrolment ratio (%) in Benin?
Your response must be concise. 58.16. In the year 1976, what is the difference between the Gross enrolment ratio (%) in Belgium and Gross enrolment ratio (%) in Cuba?
Offer a very short reply. -16.34. In the year 1976, what is the difference between the Gross enrolment ratio (%) of Belgium and Gross enrolment ratio (%) of Macao?
Your response must be concise. 31.4. In the year 1976, what is the difference between the Gross enrolment ratio (%) in Benin and Gross enrolment ratio (%) in Cuba?
Offer a terse response. -74.49. In the year 1976, what is the difference between the Gross enrolment ratio (%) in Benin and Gross enrolment ratio (%) in Macao?
Provide a short and direct response. -26.75. In the year 1976, what is the difference between the Gross enrolment ratio (%) of Cuba and Gross enrolment ratio (%) of Macao?
Provide a succinct answer. 47.74. In the year 1977, what is the difference between the Gross enrolment ratio (%) in Belgium and Gross enrolment ratio (%) in Benin?
Your answer should be very brief. 56.81. In the year 1977, what is the difference between the Gross enrolment ratio (%) of Belgium and Gross enrolment ratio (%) of Cuba?
Provide a succinct answer. -14.4. In the year 1977, what is the difference between the Gross enrolment ratio (%) of Belgium and Gross enrolment ratio (%) of Macao?
Keep it short and to the point. 11.4. In the year 1977, what is the difference between the Gross enrolment ratio (%) in Benin and Gross enrolment ratio (%) in Cuba?
Give a very brief answer. -71.21. In the year 1977, what is the difference between the Gross enrolment ratio (%) in Benin and Gross enrolment ratio (%) in Macao?
Your answer should be very brief. -45.41. In the year 1977, what is the difference between the Gross enrolment ratio (%) of Cuba and Gross enrolment ratio (%) of Macao?
Provide a succinct answer. 25.79. In the year 1978, what is the difference between the Gross enrolment ratio (%) of Belgium and Gross enrolment ratio (%) of Benin?
Your answer should be very brief. 56.06. In the year 1978, what is the difference between the Gross enrolment ratio (%) in Belgium and Gross enrolment ratio (%) in Cuba?
Give a very brief answer. -11.99. In the year 1978, what is the difference between the Gross enrolment ratio (%) in Belgium and Gross enrolment ratio (%) in Macao?
Offer a terse response. 15.38. In the year 1978, what is the difference between the Gross enrolment ratio (%) of Benin and Gross enrolment ratio (%) of Cuba?
Make the answer very short. -68.05. In the year 1978, what is the difference between the Gross enrolment ratio (%) in Benin and Gross enrolment ratio (%) in Macao?
Provide a succinct answer. -40.68. In the year 1978, what is the difference between the Gross enrolment ratio (%) in Cuba and Gross enrolment ratio (%) in Macao?
Give a very brief answer. 27.37. In the year 1979, what is the difference between the Gross enrolment ratio (%) of Belgium and Gross enrolment ratio (%) of Benin?
Your response must be concise. 49.41. In the year 1979, what is the difference between the Gross enrolment ratio (%) of Belgium and Gross enrolment ratio (%) of Cuba?
Make the answer very short. -8.94. In the year 1979, what is the difference between the Gross enrolment ratio (%) of Belgium and Gross enrolment ratio (%) of Macao?
Your answer should be compact. 5.52. In the year 1979, what is the difference between the Gross enrolment ratio (%) of Benin and Gross enrolment ratio (%) of Cuba?
Keep it short and to the point. -58.35. In the year 1979, what is the difference between the Gross enrolment ratio (%) in Benin and Gross enrolment ratio (%) in Macao?
Make the answer very short. -43.89. In the year 1979, what is the difference between the Gross enrolment ratio (%) of Cuba and Gross enrolment ratio (%) of Macao?
Your answer should be compact. 14.46. In the year 1989, what is the difference between the Gross enrolment ratio (%) of Belgium and Gross enrolment ratio (%) of Benin?
Provide a succinct answer. 40.34. In the year 1989, what is the difference between the Gross enrolment ratio (%) in Belgium and Gross enrolment ratio (%) in Cuba?
Ensure brevity in your answer.  0.23. In the year 1989, what is the difference between the Gross enrolment ratio (%) of Belgium and Gross enrolment ratio (%) of Macao?
Give a very brief answer. -11.49. In the year 1989, what is the difference between the Gross enrolment ratio (%) of Benin and Gross enrolment ratio (%) of Cuba?
Your response must be concise. -40.1. In the year 1989, what is the difference between the Gross enrolment ratio (%) in Benin and Gross enrolment ratio (%) in Macao?
Keep it short and to the point. -51.83. In the year 1989, what is the difference between the Gross enrolment ratio (%) in Cuba and Gross enrolment ratio (%) in Macao?
Provide a succinct answer. -11.73. In the year 1990, what is the difference between the Gross enrolment ratio (%) of Belgium and Gross enrolment ratio (%) of Benin?
Provide a short and direct response. 49.58. In the year 1990, what is the difference between the Gross enrolment ratio (%) in Belgium and Gross enrolment ratio (%) in Macao?
Give a very brief answer. -6.18. In the year 1990, what is the difference between the Gross enrolment ratio (%) of Benin and Gross enrolment ratio (%) of Cuba?
Your answer should be compact. -48.58. In the year 1990, what is the difference between the Gross enrolment ratio (%) of Benin and Gross enrolment ratio (%) of Macao?
Offer a terse response. -55.75. In the year 1990, what is the difference between the Gross enrolment ratio (%) of Cuba and Gross enrolment ratio (%) of Macao?
Give a very brief answer. -7.17. In the year 1991, what is the difference between the Gross enrolment ratio (%) of Belgium and Gross enrolment ratio (%) of Benin?
Give a very brief answer. 41.9. In the year 1991, what is the difference between the Gross enrolment ratio (%) in Belgium and Gross enrolment ratio (%) in Cuba?
Make the answer very short. 1.84. In the year 1991, what is the difference between the Gross enrolment ratio (%) in Belgium and Gross enrolment ratio (%) in Macao?
Provide a short and direct response. -5.88. In the year 1991, what is the difference between the Gross enrolment ratio (%) in Benin and Gross enrolment ratio (%) in Cuba?
Provide a succinct answer. -40.05. In the year 1991, what is the difference between the Gross enrolment ratio (%) of Benin and Gross enrolment ratio (%) of Macao?
Give a very brief answer. -47.77. In the year 1991, what is the difference between the Gross enrolment ratio (%) of Cuba and Gross enrolment ratio (%) of Macao?
Offer a terse response. -7.72. What is the ratio of the Gross enrolment ratio (%) in Benin in 1975 to that in 1976?
Offer a terse response. 0.96. What is the ratio of the Gross enrolment ratio (%) in Cuba in 1975 to that in 1976?
Ensure brevity in your answer.  0.99. What is the ratio of the Gross enrolment ratio (%) of Macao in 1975 to that in 1976?
Keep it short and to the point. 0.87. What is the ratio of the Gross enrolment ratio (%) of Belgium in 1975 to that in 1977?
Your answer should be compact. 0.98. What is the ratio of the Gross enrolment ratio (%) of Benin in 1975 to that in 1977?
Offer a very short reply. 0.92. What is the ratio of the Gross enrolment ratio (%) in Cuba in 1975 to that in 1977?
Make the answer very short. 1. What is the ratio of the Gross enrolment ratio (%) of Macao in 1975 to that in 1977?
Provide a short and direct response. 0.68. What is the ratio of the Gross enrolment ratio (%) in Belgium in 1975 to that in 1978?
Your answer should be compact. 0.98. What is the ratio of the Gross enrolment ratio (%) in Benin in 1975 to that in 1978?
Provide a short and direct response. 0.91. What is the ratio of the Gross enrolment ratio (%) of Cuba in 1975 to that in 1978?
Give a very brief answer. 1.02. What is the ratio of the Gross enrolment ratio (%) in Macao in 1975 to that in 1978?
Make the answer very short. 0.71. What is the ratio of the Gross enrolment ratio (%) in Belgium in 1975 to that in 1979?
Make the answer very short. 0.99. What is the ratio of the Gross enrolment ratio (%) in Benin in 1975 to that in 1979?
Offer a very short reply. 0.81. What is the ratio of the Gross enrolment ratio (%) in Cuba in 1975 to that in 1979?
Offer a terse response. 1.05. What is the ratio of the Gross enrolment ratio (%) of Macao in 1975 to that in 1979?
Ensure brevity in your answer.  0.64. What is the ratio of the Gross enrolment ratio (%) in Belgium in 1975 to that in 1989?
Provide a succinct answer. 1.04. What is the ratio of the Gross enrolment ratio (%) in Benin in 1975 to that in 1989?
Your answer should be compact. 0.75. What is the ratio of the Gross enrolment ratio (%) of Cuba in 1975 to that in 1989?
Keep it short and to the point. 1.2. What is the ratio of the Gross enrolment ratio (%) of Macao in 1975 to that in 1989?
Offer a terse response. 0.57. What is the ratio of the Gross enrolment ratio (%) in Belgium in 1975 to that in 1990?
Provide a succinct answer. 1.04. What is the ratio of the Gross enrolment ratio (%) in Benin in 1975 to that in 1990?
Provide a succinct answer. 0.9. What is the ratio of the Gross enrolment ratio (%) of Cuba in 1975 to that in 1990?
Offer a terse response. 1.21. What is the ratio of the Gross enrolment ratio (%) in Macao in 1975 to that in 1990?
Provide a short and direct response. 0.6. What is the ratio of the Gross enrolment ratio (%) of Belgium in 1975 to that in 1991?
Ensure brevity in your answer.  1.05. What is the ratio of the Gross enrolment ratio (%) in Benin in 1975 to that in 1991?
Provide a succinct answer. 0.79. What is the ratio of the Gross enrolment ratio (%) in Cuba in 1975 to that in 1991?
Give a very brief answer. 1.23. What is the ratio of the Gross enrolment ratio (%) in Macao in 1975 to that in 1991?
Ensure brevity in your answer.  0.61. What is the ratio of the Gross enrolment ratio (%) of Belgium in 1976 to that in 1977?
Ensure brevity in your answer.  0.99. What is the ratio of the Gross enrolment ratio (%) in Benin in 1976 to that in 1977?
Provide a succinct answer. 0.96. What is the ratio of the Gross enrolment ratio (%) in Cuba in 1976 to that in 1977?
Your answer should be very brief. 1.01. What is the ratio of the Gross enrolment ratio (%) of Macao in 1976 to that in 1977?
Your response must be concise. 0.78. What is the ratio of the Gross enrolment ratio (%) of Benin in 1976 to that in 1978?
Provide a succinct answer. 0.94. What is the ratio of the Gross enrolment ratio (%) of Cuba in 1976 to that in 1978?
Provide a succinct answer. 1.03. What is the ratio of the Gross enrolment ratio (%) in Macao in 1976 to that in 1978?
Your answer should be compact. 0.82. What is the ratio of the Gross enrolment ratio (%) in Belgium in 1976 to that in 1979?
Offer a terse response. 1. What is the ratio of the Gross enrolment ratio (%) in Benin in 1976 to that in 1979?
Your answer should be compact. 0.84. What is the ratio of the Gross enrolment ratio (%) in Cuba in 1976 to that in 1979?
Your answer should be compact. 1.06. What is the ratio of the Gross enrolment ratio (%) of Macao in 1976 to that in 1979?
Your response must be concise. 0.74. What is the ratio of the Gross enrolment ratio (%) in Belgium in 1976 to that in 1989?
Ensure brevity in your answer.  1.05. What is the ratio of the Gross enrolment ratio (%) in Benin in 1976 to that in 1989?
Your answer should be very brief. 0.78. What is the ratio of the Gross enrolment ratio (%) in Cuba in 1976 to that in 1989?
Offer a terse response. 1.21. What is the ratio of the Gross enrolment ratio (%) of Macao in 1976 to that in 1989?
Keep it short and to the point. 0.66. What is the ratio of the Gross enrolment ratio (%) in Belgium in 1976 to that in 1990?
Provide a short and direct response. 1.05. What is the ratio of the Gross enrolment ratio (%) in Benin in 1976 to that in 1990?
Keep it short and to the point. 0.93. What is the ratio of the Gross enrolment ratio (%) of Cuba in 1976 to that in 1990?
Offer a very short reply. 1.23. What is the ratio of the Gross enrolment ratio (%) in Macao in 1976 to that in 1990?
Keep it short and to the point. 0.7. What is the ratio of the Gross enrolment ratio (%) in Belgium in 1976 to that in 1991?
Your answer should be compact. 1.06. What is the ratio of the Gross enrolment ratio (%) of Benin in 1976 to that in 1991?
Keep it short and to the point. 0.82. What is the ratio of the Gross enrolment ratio (%) in Cuba in 1976 to that in 1991?
Your response must be concise. 1.25. What is the ratio of the Gross enrolment ratio (%) of Macao in 1976 to that in 1991?
Make the answer very short. 0.7. What is the ratio of the Gross enrolment ratio (%) in Belgium in 1977 to that in 1978?
Ensure brevity in your answer.  1. What is the ratio of the Gross enrolment ratio (%) in Benin in 1977 to that in 1978?
Your response must be concise. 0.98. What is the ratio of the Gross enrolment ratio (%) in Cuba in 1977 to that in 1978?
Ensure brevity in your answer.  1.02. What is the ratio of the Gross enrolment ratio (%) of Macao in 1977 to that in 1978?
Give a very brief answer. 1.04. What is the ratio of the Gross enrolment ratio (%) of Benin in 1977 to that in 1979?
Ensure brevity in your answer.  0.88. What is the ratio of the Gross enrolment ratio (%) of Cuba in 1977 to that in 1979?
Your answer should be compact. 1.05. What is the ratio of the Gross enrolment ratio (%) of Belgium in 1977 to that in 1989?
Provide a short and direct response. 1.05. What is the ratio of the Gross enrolment ratio (%) in Benin in 1977 to that in 1989?
Provide a succinct answer. 0.82. What is the ratio of the Gross enrolment ratio (%) of Cuba in 1977 to that in 1989?
Ensure brevity in your answer.  1.2. What is the ratio of the Gross enrolment ratio (%) of Macao in 1977 to that in 1989?
Offer a very short reply. 0.84. What is the ratio of the Gross enrolment ratio (%) of Belgium in 1977 to that in 1990?
Offer a very short reply. 1.06. What is the ratio of the Gross enrolment ratio (%) of Benin in 1977 to that in 1990?
Provide a short and direct response. 0.97. What is the ratio of the Gross enrolment ratio (%) in Cuba in 1977 to that in 1990?
Your answer should be very brief. 1.21. What is the ratio of the Gross enrolment ratio (%) of Macao in 1977 to that in 1990?
Ensure brevity in your answer.  0.89. What is the ratio of the Gross enrolment ratio (%) of Belgium in 1977 to that in 1991?
Make the answer very short. 1.07. What is the ratio of the Gross enrolment ratio (%) of Benin in 1977 to that in 1991?
Keep it short and to the point. 0.86. What is the ratio of the Gross enrolment ratio (%) in Cuba in 1977 to that in 1991?
Provide a succinct answer. 1.23. What is the ratio of the Gross enrolment ratio (%) in Macao in 1977 to that in 1991?
Give a very brief answer. 0.9. What is the ratio of the Gross enrolment ratio (%) in Belgium in 1978 to that in 1979?
Give a very brief answer. 1.01. What is the ratio of the Gross enrolment ratio (%) of Benin in 1978 to that in 1979?
Ensure brevity in your answer.  0.89. What is the ratio of the Gross enrolment ratio (%) in Cuba in 1978 to that in 1979?
Your response must be concise. 1.03. What is the ratio of the Gross enrolment ratio (%) in Macao in 1978 to that in 1979?
Give a very brief answer. 0.91. What is the ratio of the Gross enrolment ratio (%) in Belgium in 1978 to that in 1989?
Ensure brevity in your answer.  1.05. What is the ratio of the Gross enrolment ratio (%) of Benin in 1978 to that in 1989?
Your answer should be very brief. 0.83. What is the ratio of the Gross enrolment ratio (%) in Cuba in 1978 to that in 1989?
Give a very brief answer. 1.17. What is the ratio of the Gross enrolment ratio (%) of Macao in 1978 to that in 1989?
Give a very brief answer. 0.81. What is the ratio of the Gross enrolment ratio (%) of Belgium in 1978 to that in 1990?
Offer a very short reply. 1.06. What is the ratio of the Gross enrolment ratio (%) of Benin in 1978 to that in 1990?
Give a very brief answer. 0.99. What is the ratio of the Gross enrolment ratio (%) in Cuba in 1978 to that in 1990?
Make the answer very short. 1.19. What is the ratio of the Gross enrolment ratio (%) in Macao in 1978 to that in 1990?
Your answer should be compact. 0.85. What is the ratio of the Gross enrolment ratio (%) in Belgium in 1978 to that in 1991?
Your answer should be compact. 1.07. What is the ratio of the Gross enrolment ratio (%) in Benin in 1978 to that in 1991?
Keep it short and to the point. 0.87. What is the ratio of the Gross enrolment ratio (%) in Cuba in 1978 to that in 1991?
Ensure brevity in your answer.  1.21. What is the ratio of the Gross enrolment ratio (%) in Macao in 1978 to that in 1991?
Provide a succinct answer. 0.86. What is the ratio of the Gross enrolment ratio (%) in Belgium in 1979 to that in 1989?
Offer a very short reply. 1.05. What is the ratio of the Gross enrolment ratio (%) of Benin in 1979 to that in 1989?
Your answer should be compact. 0.93. What is the ratio of the Gross enrolment ratio (%) of Cuba in 1979 to that in 1989?
Offer a terse response. 1.14. What is the ratio of the Gross enrolment ratio (%) in Macao in 1979 to that in 1989?
Ensure brevity in your answer.  0.89. What is the ratio of the Gross enrolment ratio (%) in Belgium in 1979 to that in 1990?
Offer a very short reply. 1.05. What is the ratio of the Gross enrolment ratio (%) in Benin in 1979 to that in 1990?
Make the answer very short. 1.11. What is the ratio of the Gross enrolment ratio (%) in Cuba in 1979 to that in 1990?
Keep it short and to the point. 1.15. What is the ratio of the Gross enrolment ratio (%) in Macao in 1979 to that in 1990?
Give a very brief answer. 0.94. What is the ratio of the Gross enrolment ratio (%) of Belgium in 1979 to that in 1991?
Offer a terse response. 1.06. What is the ratio of the Gross enrolment ratio (%) of Benin in 1979 to that in 1991?
Your answer should be compact. 0.98. What is the ratio of the Gross enrolment ratio (%) of Cuba in 1979 to that in 1991?
Your answer should be compact. 1.17. What is the ratio of the Gross enrolment ratio (%) of Benin in 1989 to that in 1990?
Provide a succinct answer. 1.19. What is the ratio of the Gross enrolment ratio (%) in Cuba in 1989 to that in 1990?
Make the answer very short. 1.01. What is the ratio of the Gross enrolment ratio (%) of Macao in 1989 to that in 1990?
Offer a very short reply. 1.06. What is the ratio of the Gross enrolment ratio (%) in Belgium in 1989 to that in 1991?
Your response must be concise. 1.01. What is the ratio of the Gross enrolment ratio (%) in Benin in 1989 to that in 1991?
Ensure brevity in your answer.  1.05. What is the ratio of the Gross enrolment ratio (%) in Cuba in 1989 to that in 1991?
Offer a terse response. 1.03. What is the ratio of the Gross enrolment ratio (%) in Macao in 1989 to that in 1991?
Your response must be concise. 1.07. What is the ratio of the Gross enrolment ratio (%) in Belgium in 1990 to that in 1991?
Give a very brief answer. 1.01. What is the ratio of the Gross enrolment ratio (%) of Benin in 1990 to that in 1991?
Provide a short and direct response. 0.88. What is the ratio of the Gross enrolment ratio (%) in Cuba in 1990 to that in 1991?
Offer a very short reply. 1.02. What is the ratio of the Gross enrolment ratio (%) of Macao in 1990 to that in 1991?
Make the answer very short. 1.01. What is the difference between the highest and the second highest Gross enrolment ratio (%) in Belgium?
Your answer should be very brief. 0.06. What is the difference between the highest and the second highest Gross enrolment ratio (%) in Benin?
Keep it short and to the point. 2.98. What is the difference between the highest and the second highest Gross enrolment ratio (%) of Cuba?
Provide a short and direct response. 1.3. What is the difference between the highest and the second highest Gross enrolment ratio (%) of Macao?
Offer a very short reply. 5.9. What is the difference between the highest and the lowest Gross enrolment ratio (%) in Belgium?
Offer a terse response. 6.78. What is the difference between the highest and the lowest Gross enrolment ratio (%) of Benin?
Provide a short and direct response. 14.93. What is the difference between the highest and the lowest Gross enrolment ratio (%) in Cuba?
Ensure brevity in your answer.  24.27. What is the difference between the highest and the lowest Gross enrolment ratio (%) in Macao?
Your response must be concise. 48.06. 